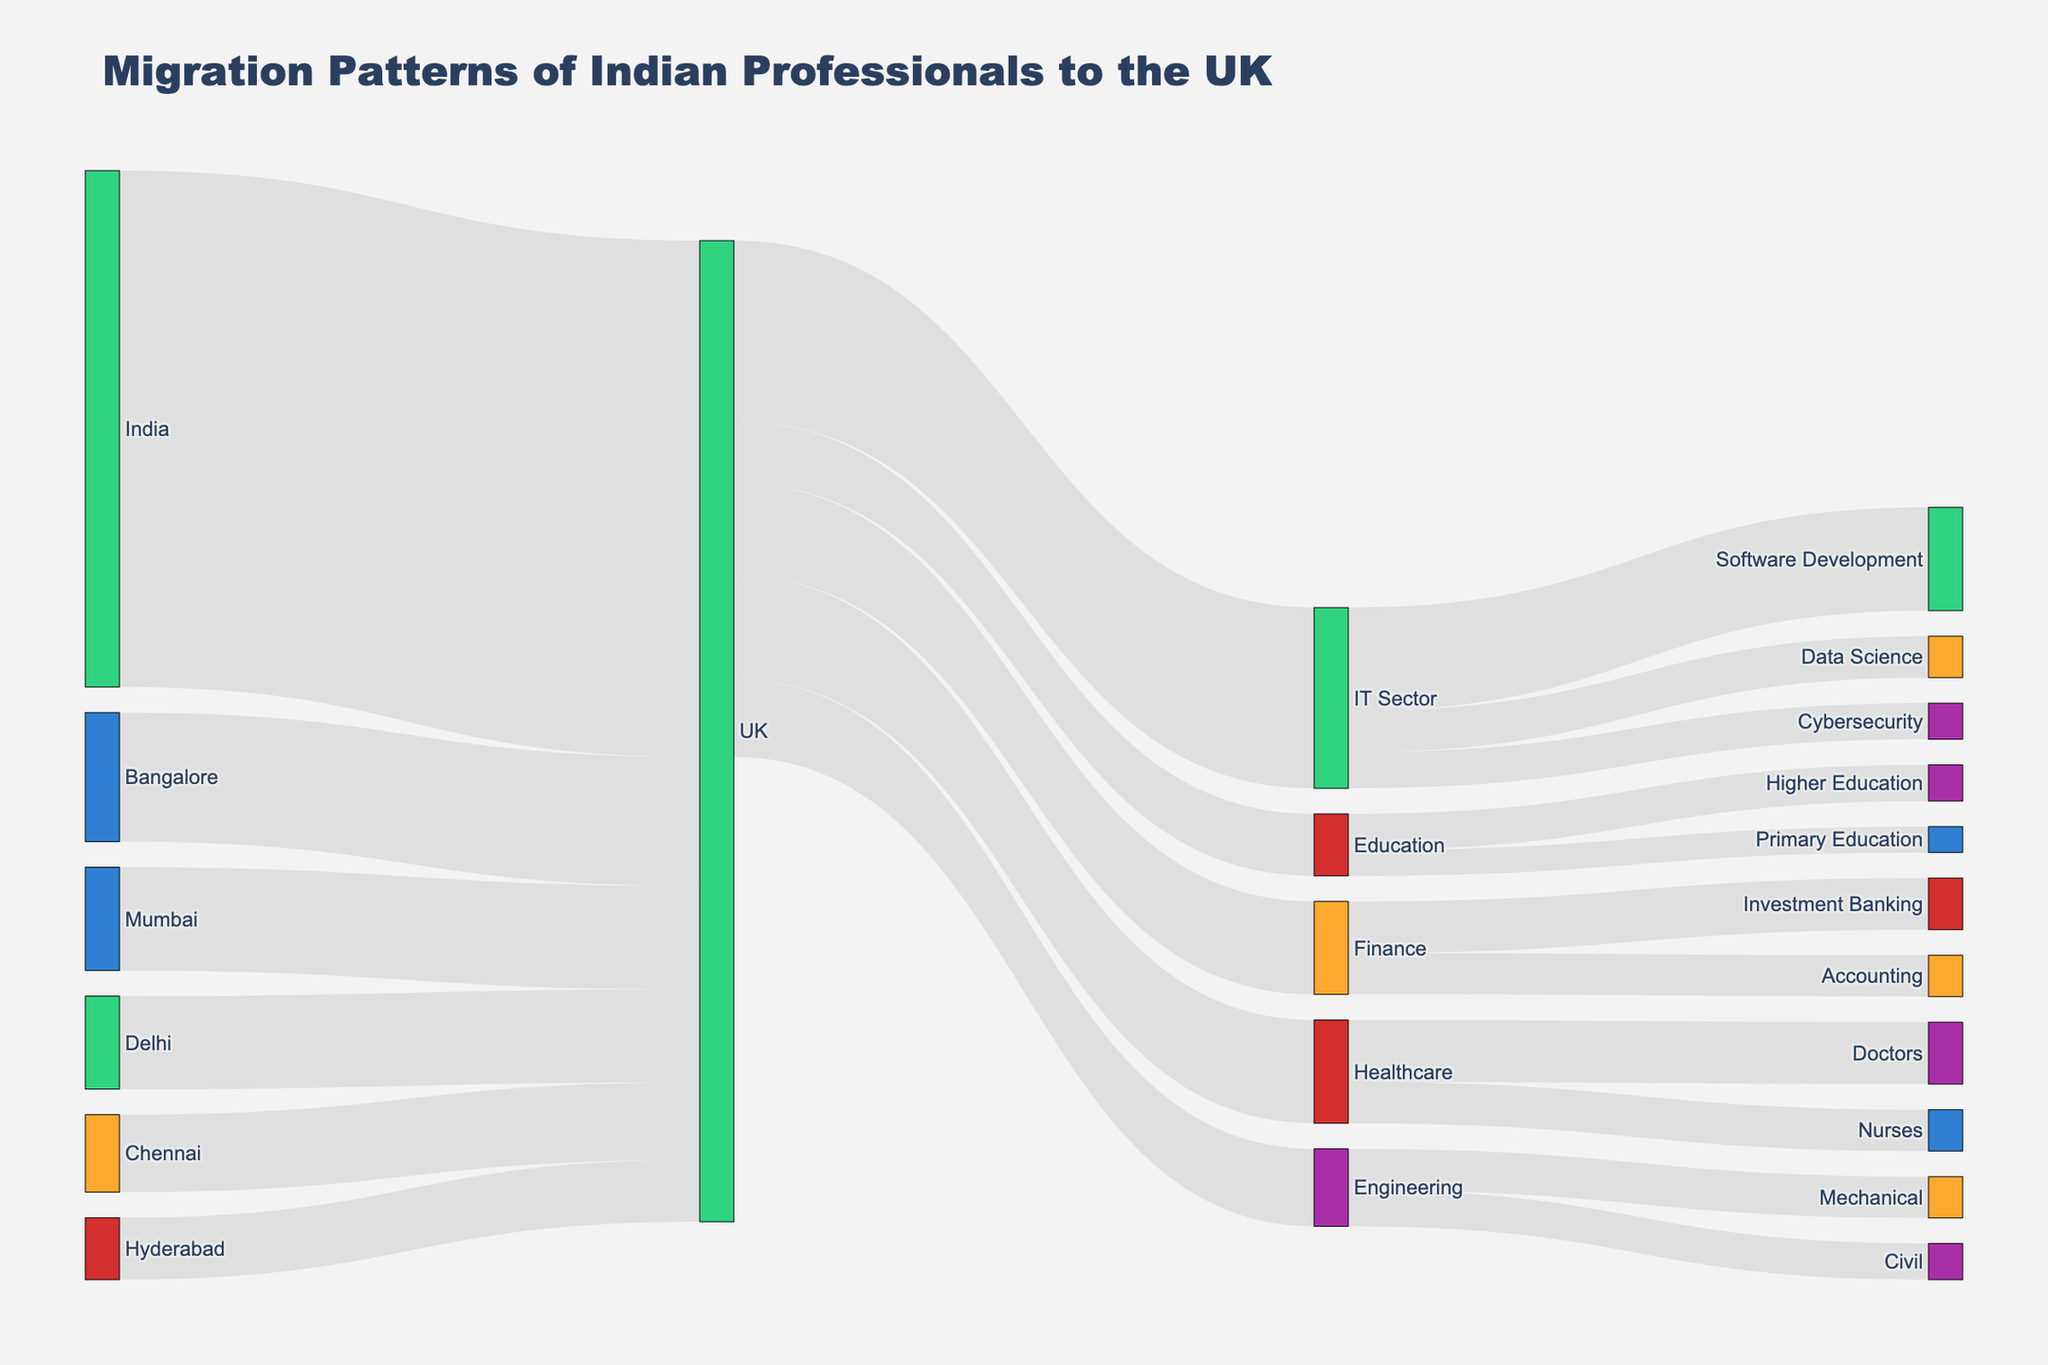How many Indian professionals migrate from Bangalore to the UK according to the diagram? There is a direct connection labeled as "Bangalore" targeting the "UK" with the value indicating the number of professionals. By looking at this link, we see it is labeled with "25000".
Answer: 25000 Which industry sector in the UK has the most Indian professionals? To determine this, we look at the segments from "UK" leading to various sectors. The segment labeled "IT Sector" has the highest value of "35000".
Answer: IT Sector What is the total number of Indian professionals migrating to the UK from all listed cities? Sum the values of the Brazilian professionals from all cities: Bangalore (25000) + Mumbai (20000) + Delhi (18000) + Chennai (15000) + Hyderabad (12000). The total is 25000 + 20000 + 18000 + 15000 + 12000 which equals 88000.
Answer: 88000 Between the Healthcare and Education sectors, which one attracts more Indian professionals in the UK? Compare the values between segments "UK" to "Healthcare" and "UK" to "Education". "Healthcare" has 20000 while "Education" has 12000. Healthcare has more.
Answer: Healthcare What is the total number of Indian professionals in the Finance sector in the UK? The Finance sector has connections labeled "Investment Banking" and "Accounting". Sum these values: Investment Banking (10000) + Accounting (8000), which equals 10000 + 8000 = 18000.
Answer: 18000 How many Indian professionals in the UK are involved in Software Development within the IT Sector? The connection from "IT Sector" to "Software Development" specifically will indicate the number of professionals. This value is "20000".
Answer: 20000 Which subsector within the IT Sector has the least number of Indian professionals? Observing the branches from "IT Sector", we compare "Software Development" (20000), "Data Science" (8000), and "Cybersecurity" (7000). The least number is in "Cybersecurity" with 7000.
Answer: Cybersecurity Are there more Indian professionals in Data Science within the IT Sector or Accounting within the Finance sector in the UK? Compare the values of "Data Science" (8000) and "Accounting" (8000) from their respective sectors. Both sectors have the same number of professionals.
Answer: Equal What is the difference in the number of professionals between the Healthcare and Engineering sectors in the UK? Compare the values "Healthcare" (20000) and "Engineering" (15000). The difference is 20000 - 15000. Thus, the difference is 5000.
Answer: 5000 In terms of origin cities, which city contributes the least number of Indian professionals migrating to the UK? Compare the values for "Bangalore" (25000), "Mumbai" (20000), "Delhi" (18000), "Chennai" (15000), and "Hyderabad" (12000). Hyderabad has the least number, with 12000.
Answer: Hyderabad 